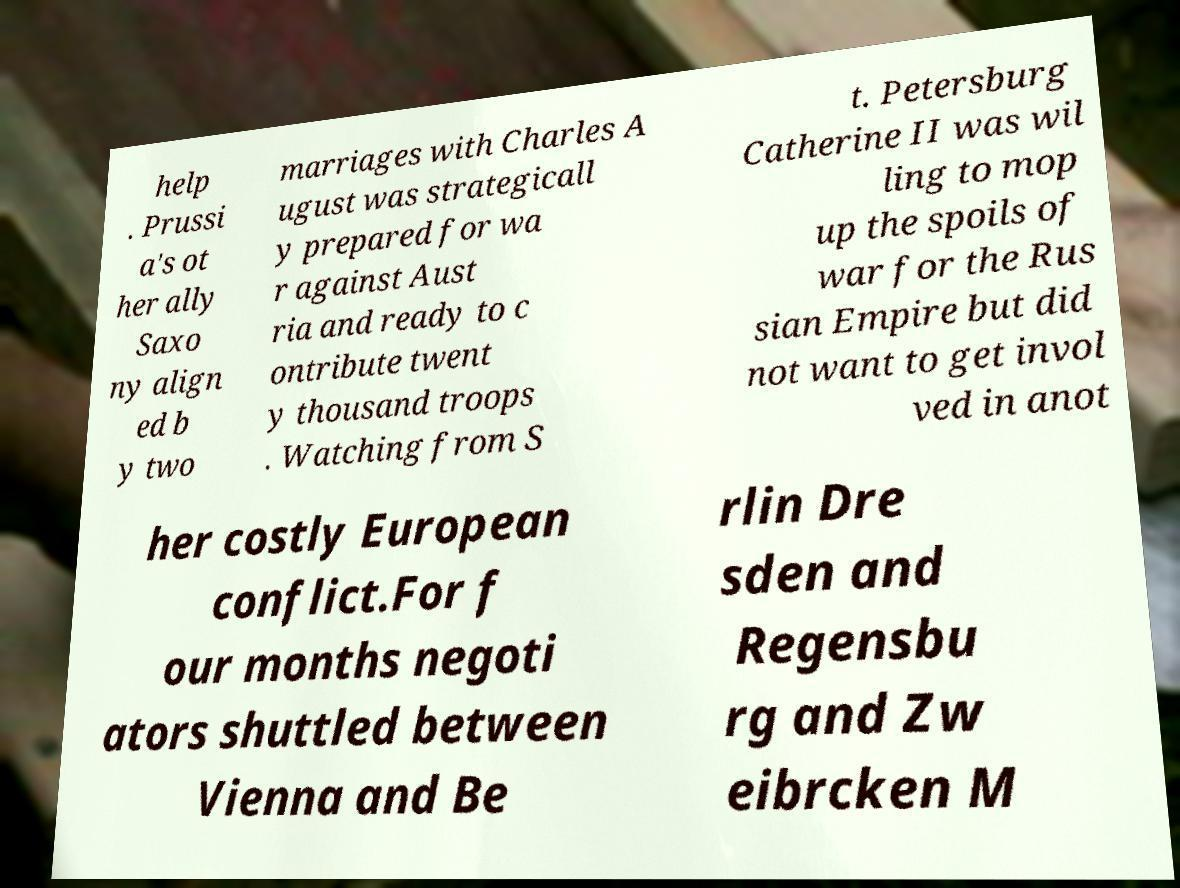Could you extract and type out the text from this image? help . Prussi a's ot her ally Saxo ny align ed b y two marriages with Charles A ugust was strategicall y prepared for wa r against Aust ria and ready to c ontribute twent y thousand troops . Watching from S t. Petersburg Catherine II was wil ling to mop up the spoils of war for the Rus sian Empire but did not want to get invol ved in anot her costly European conflict.For f our months negoti ators shuttled between Vienna and Be rlin Dre sden and Regensbu rg and Zw eibrcken M 